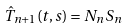<formula> <loc_0><loc_0><loc_500><loc_500>\hat { T } _ { n + 1 } ( t , s ) = N _ { n } S _ { n }</formula> 